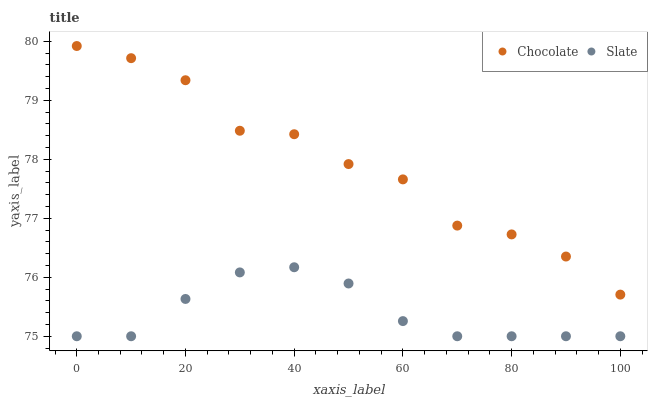Does Slate have the minimum area under the curve?
Answer yes or no. Yes. Does Chocolate have the maximum area under the curve?
Answer yes or no. Yes. Does Chocolate have the minimum area under the curve?
Answer yes or no. No. Is Slate the smoothest?
Answer yes or no. Yes. Is Chocolate the roughest?
Answer yes or no. Yes. Is Chocolate the smoothest?
Answer yes or no. No. Does Slate have the lowest value?
Answer yes or no. Yes. Does Chocolate have the lowest value?
Answer yes or no. No. Does Chocolate have the highest value?
Answer yes or no. Yes. Is Slate less than Chocolate?
Answer yes or no. Yes. Is Chocolate greater than Slate?
Answer yes or no. Yes. Does Slate intersect Chocolate?
Answer yes or no. No. 